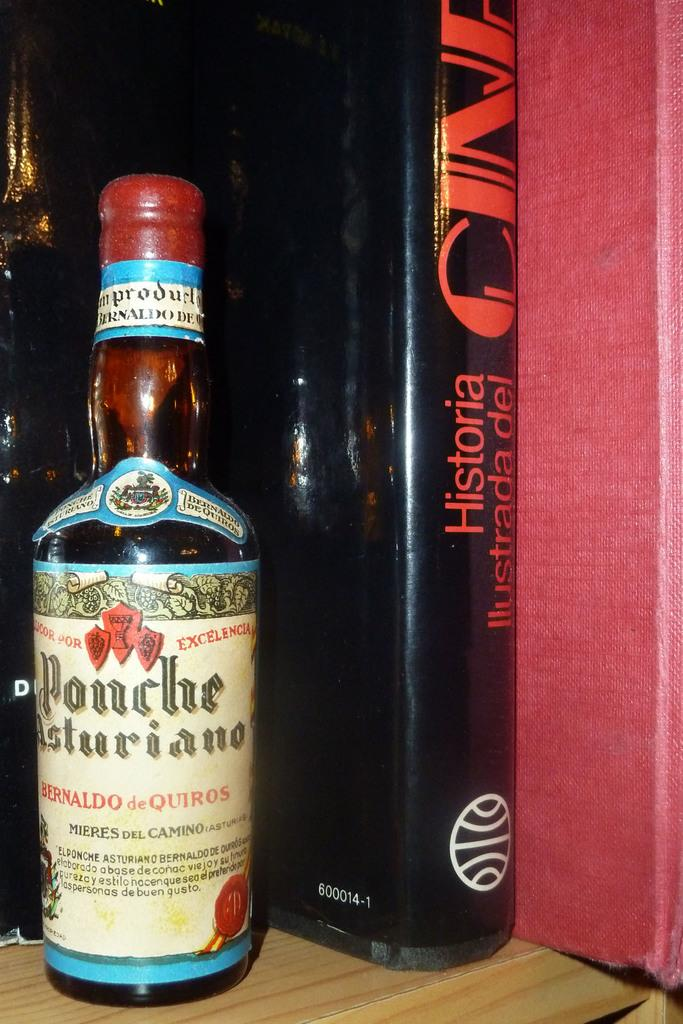<image>
Render a clear and concise summary of the photo. Bottle of ponche asturiano sits next to a book on a red background. 